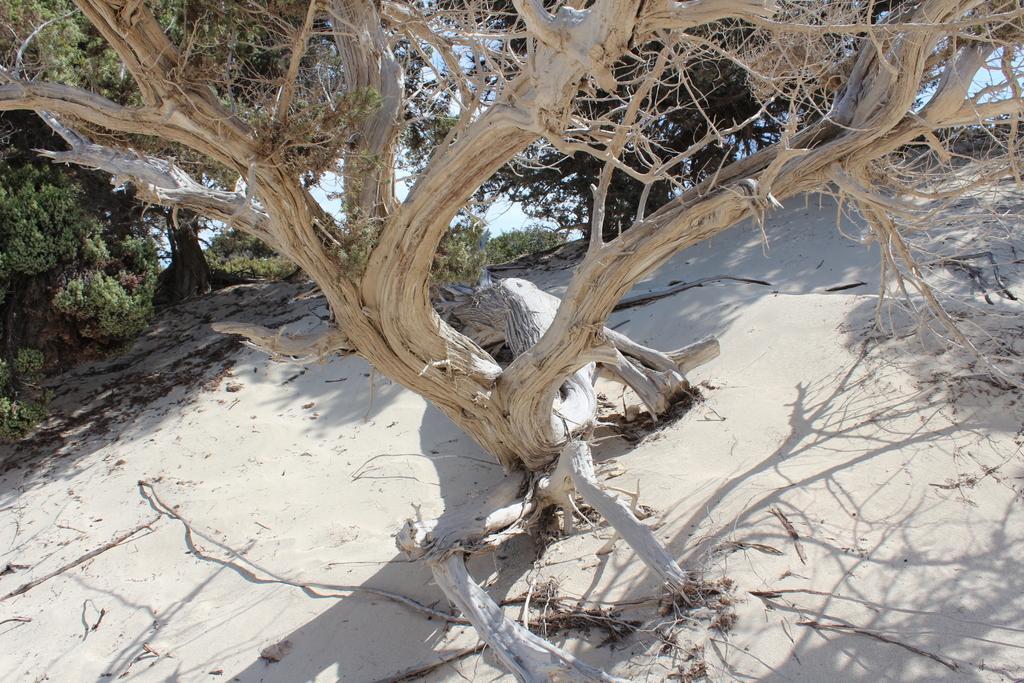How would you summarize this image in a sentence or two? In this image we can see trees on a sandy land and there is a sky in the background. 